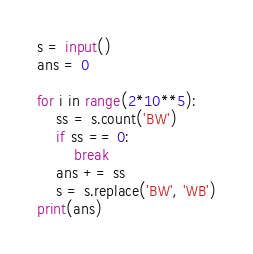<code> <loc_0><loc_0><loc_500><loc_500><_Python_>s = input()
ans = 0

for i in range(2*10**5):
    ss = s.count('BW')
    if ss == 0:
        break
    ans += ss
    s = s.replace('BW', 'WB')
print(ans)</code> 